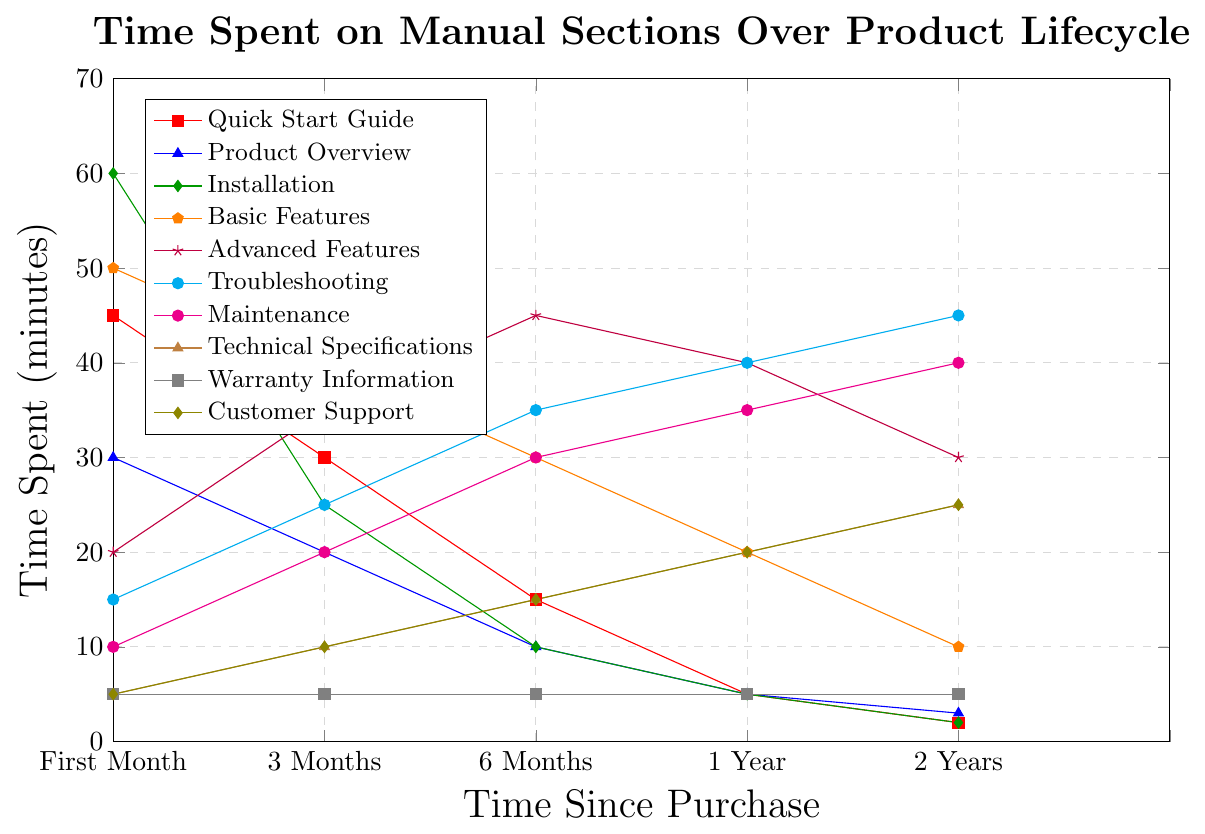Which section gets the most attention in the first month? Observing the heights of the marks in the first month, it's evident that the "Installation" section has the highest value, which is 60 minutes.
Answer: Installation How does the time spent on the Quick Start Guide change over 2 years? The values for the Quick Start Guide over time are 45, 30, 15, 5, and 2. It decreases consistently each period.
Answer: Decreases consistently Between the Basic Features and Advanced Features sections, which one gets more attention after 6 months? Checking the 6-month values, Basic Features has 30 minutes, while Advanced Features has 45 minutes, making Advanced Features higher.
Answer: Advanced Features What is the total time spent on the Troubleshooting section over the entire lifecycle? Adding up the Troubleshooting times: 15 + 25 + 35 + 40 + 45 = 160 minutes.
Answer: 160 minutes What happens to the time spent on Maintenance from the 3-month to the 2-year mark? The values for Maintenance from 3-month to 2-year are 20, 30, 35, and 40. It increases each period.
Answer: Increases Which section consistently has the lowest amount of time spent across all periods? Examining all sections, the "Warranty Information" section remains flat at 5 minutes, which is the lowest throughout all periods.
Answer: Warranty Information Which two sections have equal time spent at the 1-year mark? Checking 1-year values, Technical Specifications and Customer Support both have 20 minutes.
Answer: Technical Specifications, Customer Support How many sections show an increase in time spent from the first month to 3 months? Quick examination reveals that Advanced Features, Troubleshooting, Maintenance, Technical Specifications, and Customer Support all increase, totalling five sections.
Answer: Five What's the combined time spent on Technical Specifications and Customer Support after 2 years? Adding the times at 2 years: Technical Specifications (25) + Customer Support (25) = 50 minutes.
Answer: 50 minutes What's the average time spent on the Installation section over the entire lifecycle? Summing up installation times: 60 + 25 + 10 + 5 + 2 = 102. There are 5 periods, so average is 102 / 5 = 20.4 minutes.
Answer: 20.4 minutes 